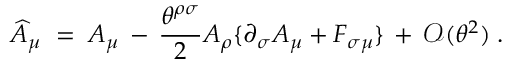<formula> <loc_0><loc_0><loc_500><loc_500>\widehat { A } _ { \mu } \, = \, A _ { \mu } \, - \, \frac { \theta ^ { \rho \sigma } } { 2 } A _ { \rho } \{ \partial _ { \sigma } A _ { \mu } + F _ { \sigma \mu } \} \, + \, { \mathcal { O } } ( \theta ^ { 2 } ) \, .</formula> 